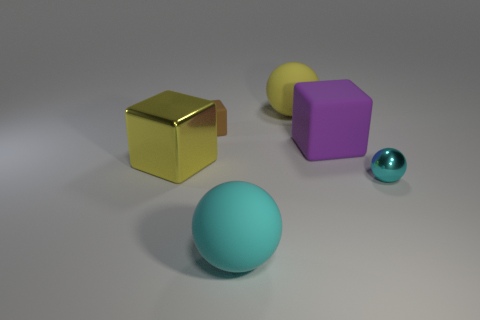Subtract all cyan shiny balls. How many balls are left? 2 Subtract all yellow balls. How many balls are left? 2 Subtract 1 blocks. How many blocks are left? 2 Add 1 tiny blocks. How many tiny blocks are left? 2 Add 4 small cyan shiny balls. How many small cyan shiny balls exist? 5 Add 2 tiny brown matte cubes. How many objects exist? 8 Subtract 0 red cylinders. How many objects are left? 6 Subtract all brown cubes. Subtract all red balls. How many cubes are left? 2 Subtract all cyan cylinders. How many purple balls are left? 0 Subtract all large yellow shiny objects. Subtract all small yellow rubber objects. How many objects are left? 5 